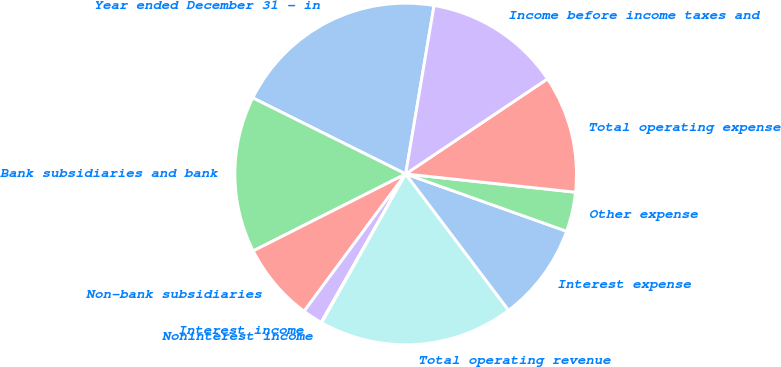Convert chart. <chart><loc_0><loc_0><loc_500><loc_500><pie_chart><fcel>Year ended December 31 - in<fcel>Bank subsidiaries and bank<fcel>Non-bank subsidiaries<fcel>Interest income<fcel>Noninterest income<fcel>Total operating revenue<fcel>Interest expense<fcel>Other expense<fcel>Total operating expense<fcel>Income before income taxes and<nl><fcel>20.3%<fcel>14.78%<fcel>7.42%<fcel>1.9%<fcel>0.06%<fcel>18.46%<fcel>9.26%<fcel>3.74%<fcel>11.1%<fcel>12.94%<nl></chart> 